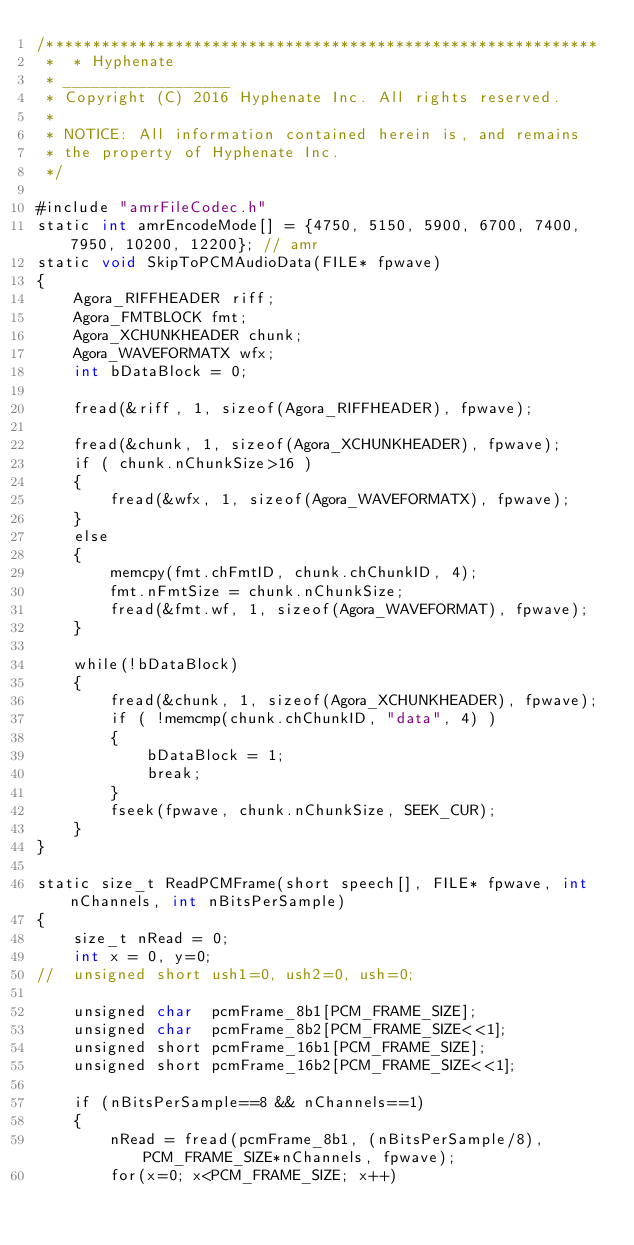<code> <loc_0><loc_0><loc_500><loc_500><_ObjectiveC_>/************************************************************
 *  * Hyphenate
 * __________________
 * Copyright (C) 2016 Hyphenate Inc. All rights reserved.
 *
 * NOTICE: All information contained herein is, and remains
 * the property of Hyphenate Inc.
 */

#include "amrFileCodec.h"
static int amrEncodeMode[] = {4750, 5150, 5900, 6700, 7400, 7950, 10200, 12200}; // amr 
static void SkipToPCMAudioData(FILE* fpwave)
{
	Agora_RIFFHEADER riff;
	Agora_FMTBLOCK fmt;
	Agora_XCHUNKHEADER chunk;
	Agora_WAVEFORMATX wfx;
	int bDataBlock = 0;
	
	fread(&riff, 1, sizeof(Agora_RIFFHEADER), fpwave);
	
	fread(&chunk, 1, sizeof(Agora_XCHUNKHEADER), fpwave);
	if ( chunk.nChunkSize>16 )
	{
		fread(&wfx, 1, sizeof(Agora_WAVEFORMATX), fpwave);
	}
	else
	{
		memcpy(fmt.chFmtID, chunk.chChunkID, 4);
		fmt.nFmtSize = chunk.nChunkSize;
		fread(&fmt.wf, 1, sizeof(Agora_WAVEFORMAT), fpwave);
	}
	
	while(!bDataBlock)
	{
		fread(&chunk, 1, sizeof(Agora_XCHUNKHEADER), fpwave);
		if ( !memcmp(chunk.chChunkID, "data", 4) )
		{
			bDataBlock = 1;
			break;
		}
		fseek(fpwave, chunk.nChunkSize, SEEK_CUR);
	}
}

static size_t ReadPCMFrame(short speech[], FILE* fpwave, int nChannels, int nBitsPerSample)
{
	size_t nRead = 0;
	int x = 0, y=0;
//	unsigned short ush1=0, ush2=0, ush=0;
	
	unsigned char  pcmFrame_8b1[PCM_FRAME_SIZE];
	unsigned char  pcmFrame_8b2[PCM_FRAME_SIZE<<1];
	unsigned short pcmFrame_16b1[PCM_FRAME_SIZE];
	unsigned short pcmFrame_16b2[PCM_FRAME_SIZE<<1];
	
	if (nBitsPerSample==8 && nChannels==1)
	{
		nRead = fread(pcmFrame_8b1, (nBitsPerSample/8), PCM_FRAME_SIZE*nChannels, fpwave);
		for(x=0; x<PCM_FRAME_SIZE; x++)</code> 